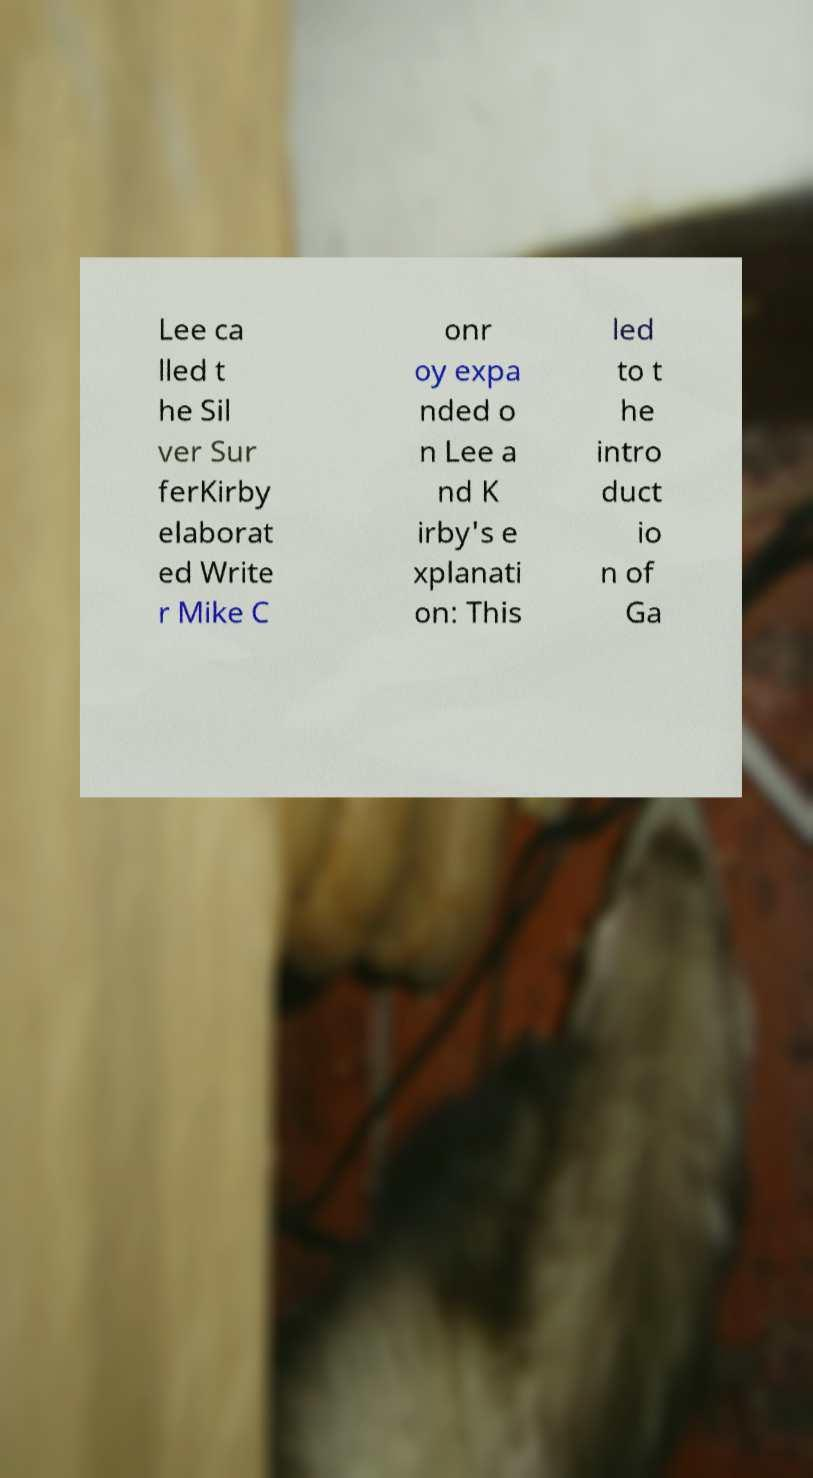What messages or text are displayed in this image? I need them in a readable, typed format. Lee ca lled t he Sil ver Sur ferKirby elaborat ed Write r Mike C onr oy expa nded o n Lee a nd K irby's e xplanati on: This led to t he intro duct io n of Ga 